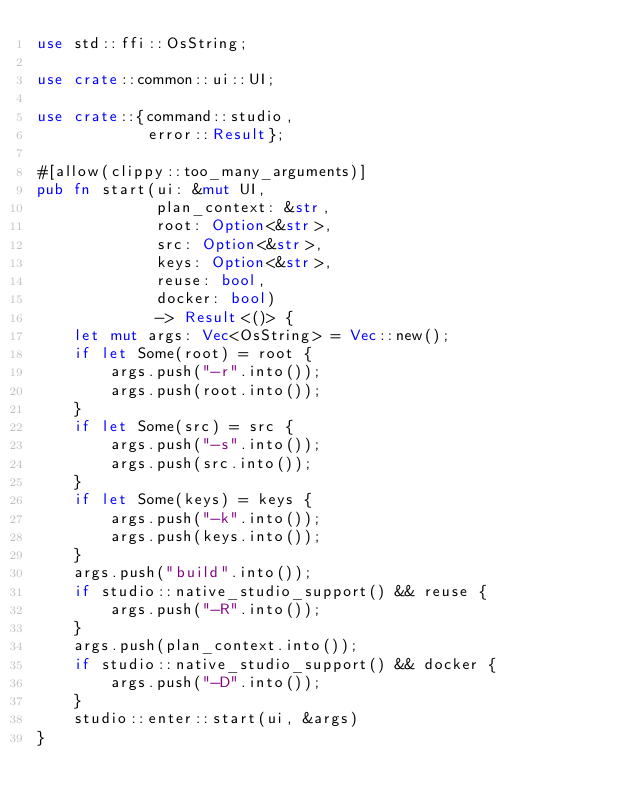<code> <loc_0><loc_0><loc_500><loc_500><_Rust_>use std::ffi::OsString;

use crate::common::ui::UI;

use crate::{command::studio,
            error::Result};

#[allow(clippy::too_many_arguments)]
pub fn start(ui: &mut UI,
             plan_context: &str,
             root: Option<&str>,
             src: Option<&str>,
             keys: Option<&str>,
             reuse: bool,
             docker: bool)
             -> Result<()> {
    let mut args: Vec<OsString> = Vec::new();
    if let Some(root) = root {
        args.push("-r".into());
        args.push(root.into());
    }
    if let Some(src) = src {
        args.push("-s".into());
        args.push(src.into());
    }
    if let Some(keys) = keys {
        args.push("-k".into());
        args.push(keys.into());
    }
    args.push("build".into());
    if studio::native_studio_support() && reuse {
        args.push("-R".into());
    }
    args.push(plan_context.into());
    if studio::native_studio_support() && docker {
        args.push("-D".into());
    }
    studio::enter::start(ui, &args)
}
</code> 